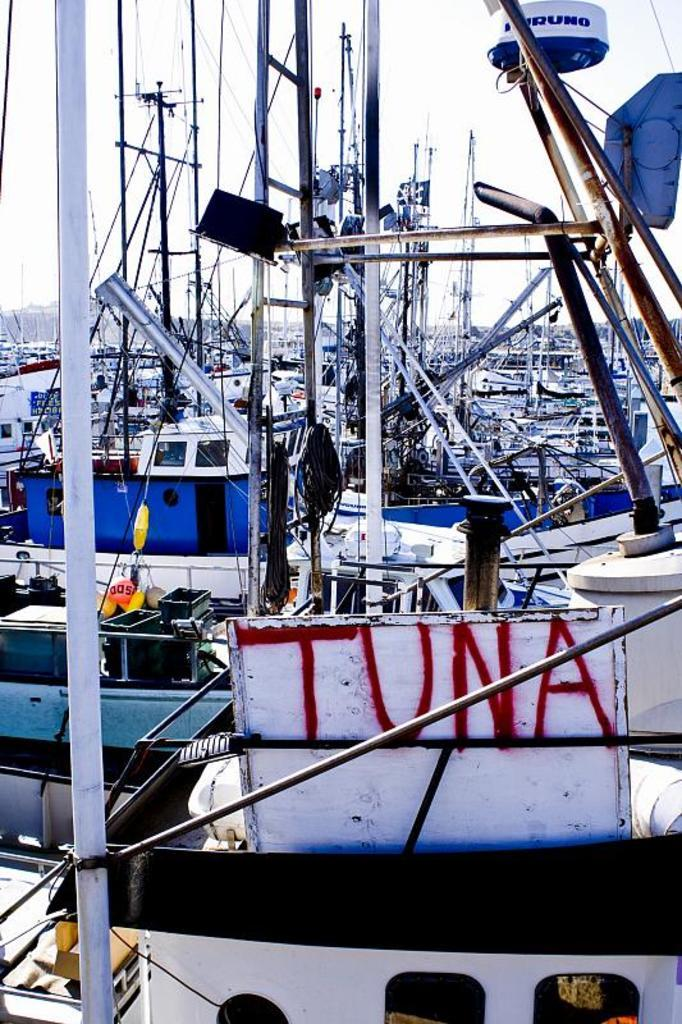What type of vehicles are in the image? There are boats in the image. What feature do the boats have? The boats have poles. What can be seen in the background of the image? There is a sky visible in the background of the image. Where are the giraffes playing in the image? There are no giraffes present in the image, and therefore no such activity can be observed. 